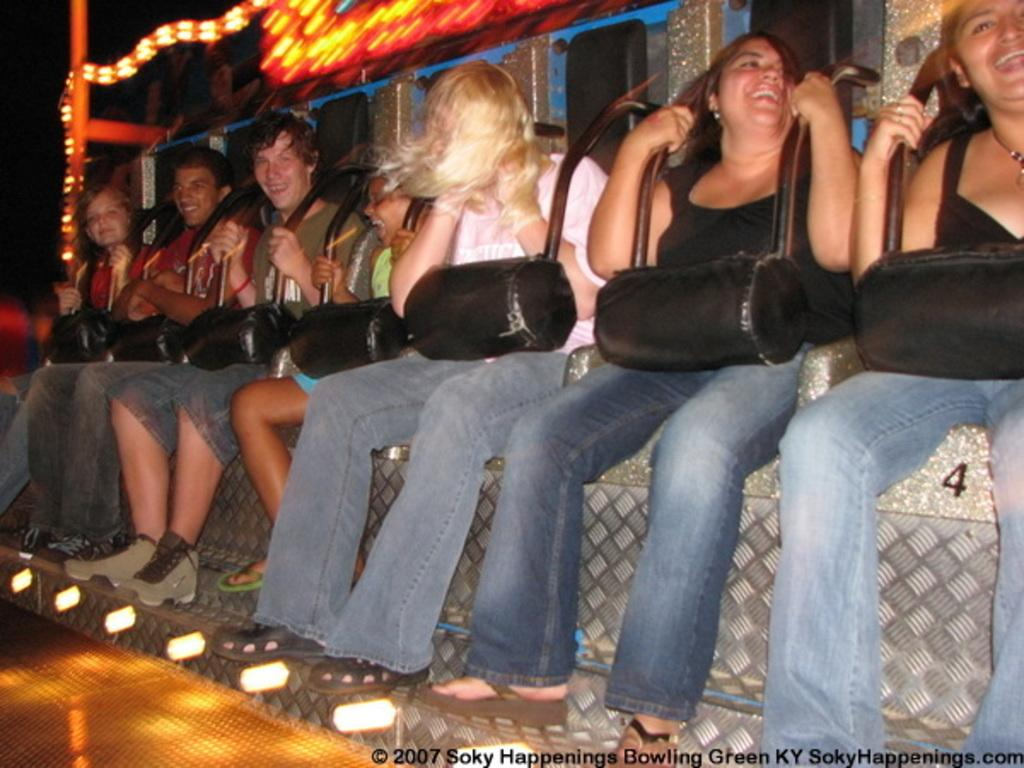What is the main subject of the image? The main subject of the image is groups of people. What are the people doing in the image? The people are sitting on an object. What can be seen in the background of the image? There are lights visible in the background of the image. How would you describe the overall lighting in the image? The background of the image is dark. What type of sofa is visible in the image? There is no sofa present in the image; the people are sitting on an object, but it is not specified as a sofa. 